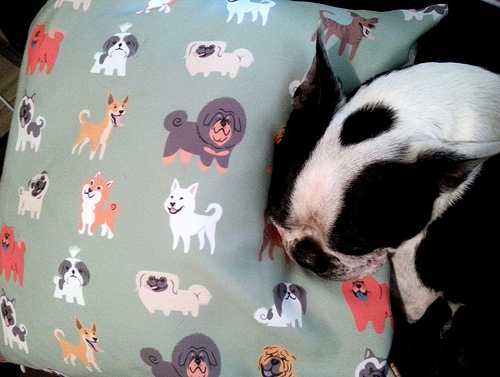<image>
Is there a dog under the pillow? No. The dog is not positioned under the pillow. The vertical relationship between these objects is different. 